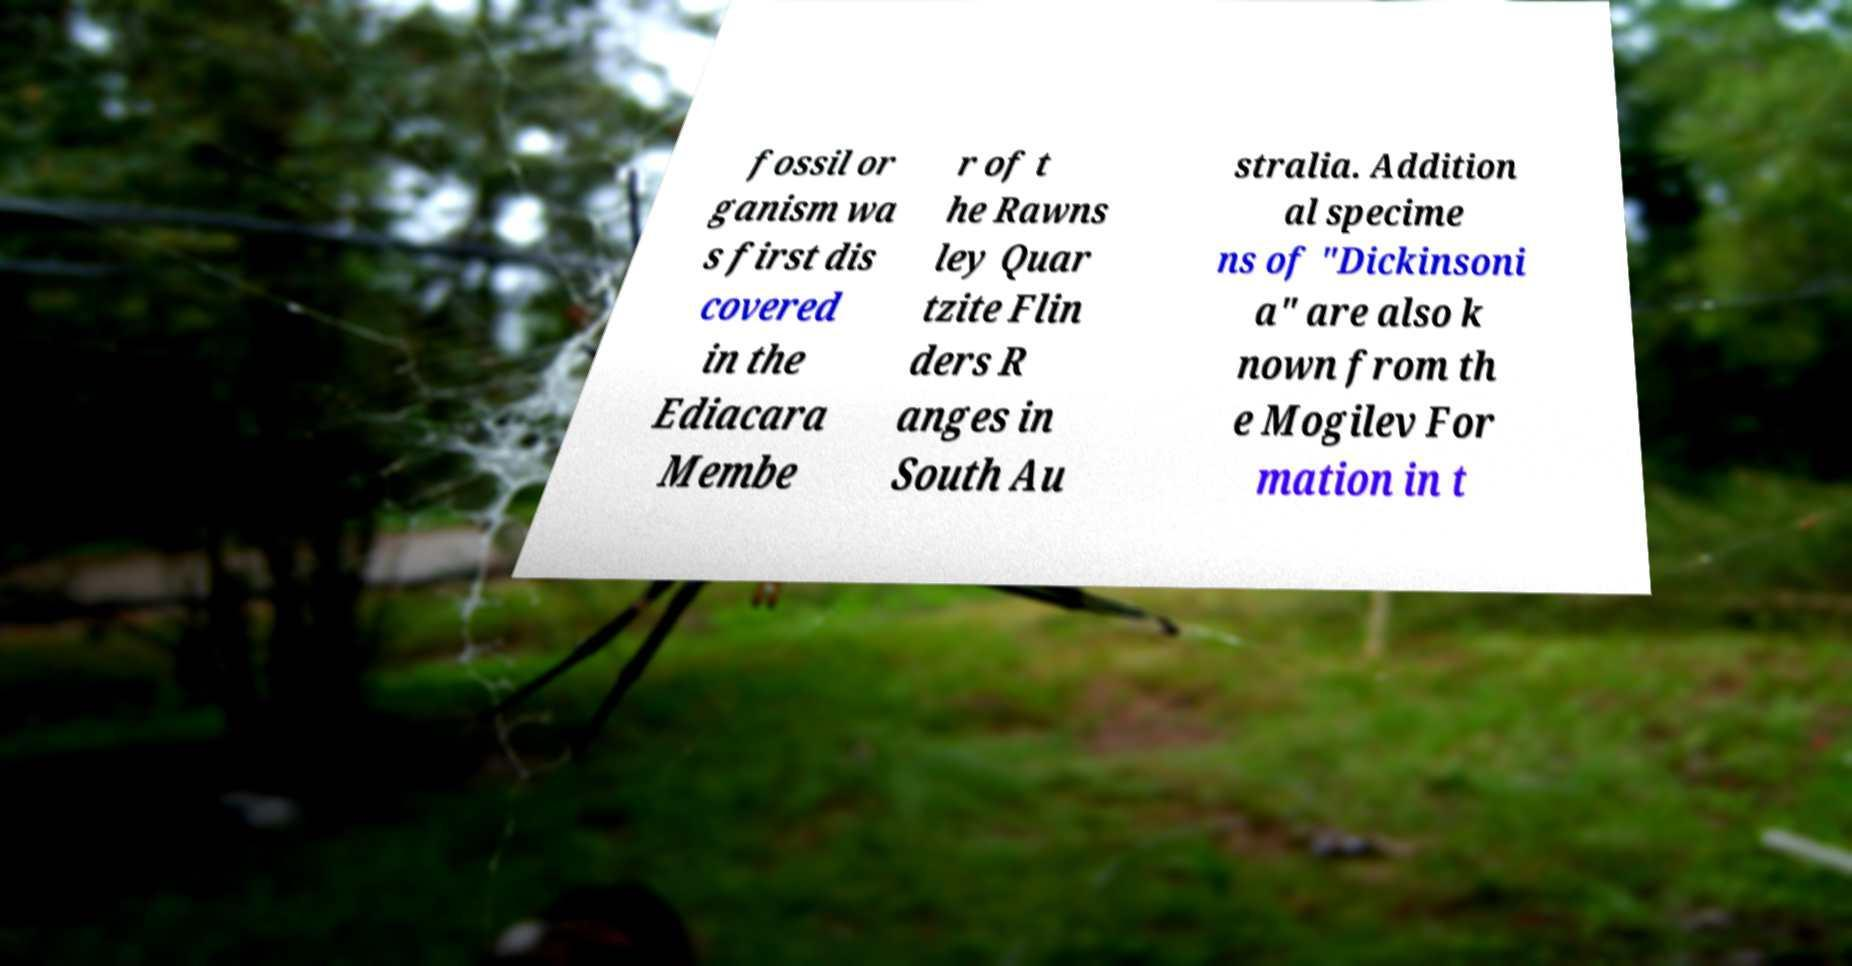Can you read and provide the text displayed in the image?This photo seems to have some interesting text. Can you extract and type it out for me? fossil or ganism wa s first dis covered in the Ediacara Membe r of t he Rawns ley Quar tzite Flin ders R anges in South Au stralia. Addition al specime ns of "Dickinsoni a" are also k nown from th e Mogilev For mation in t 